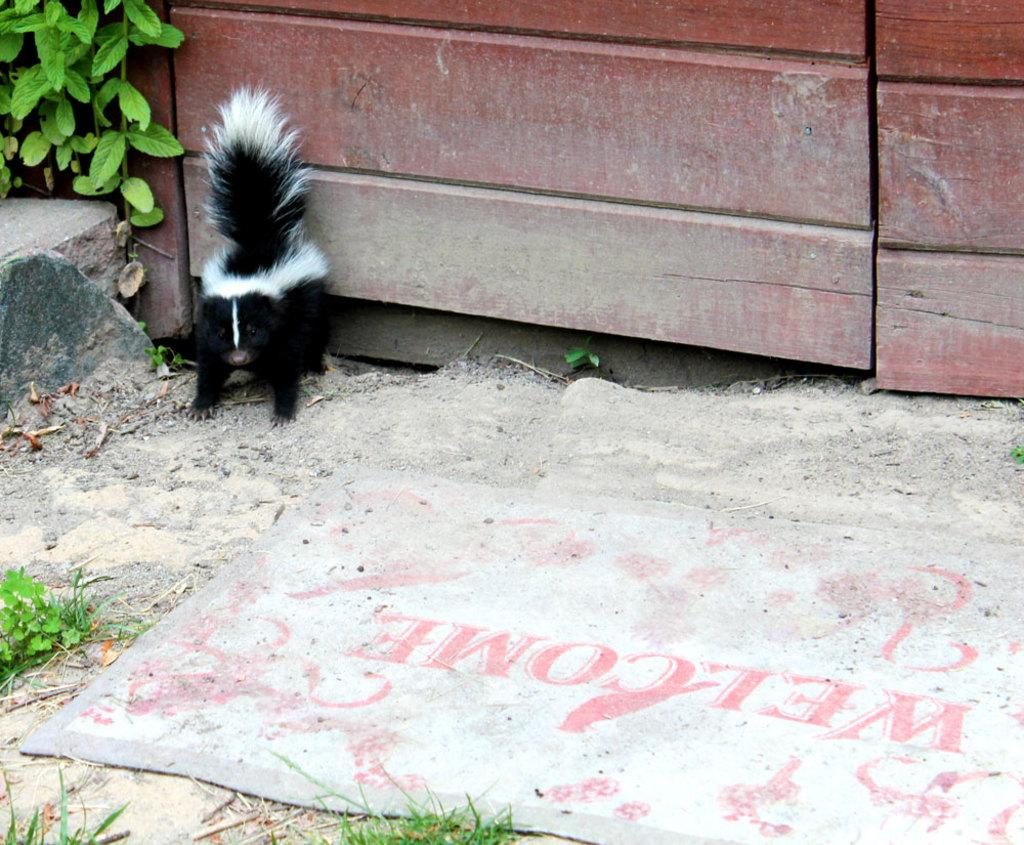What type of animal is in the image? The animal in the image is in black and white color. Can you describe the background of the image? There is a wooden door and plants in green color in the background of the image. What type of butter is being used by the animal in the image? There is no butter present in the image, as it features an animal in black and white color with a wooden door and green plants in the background. 